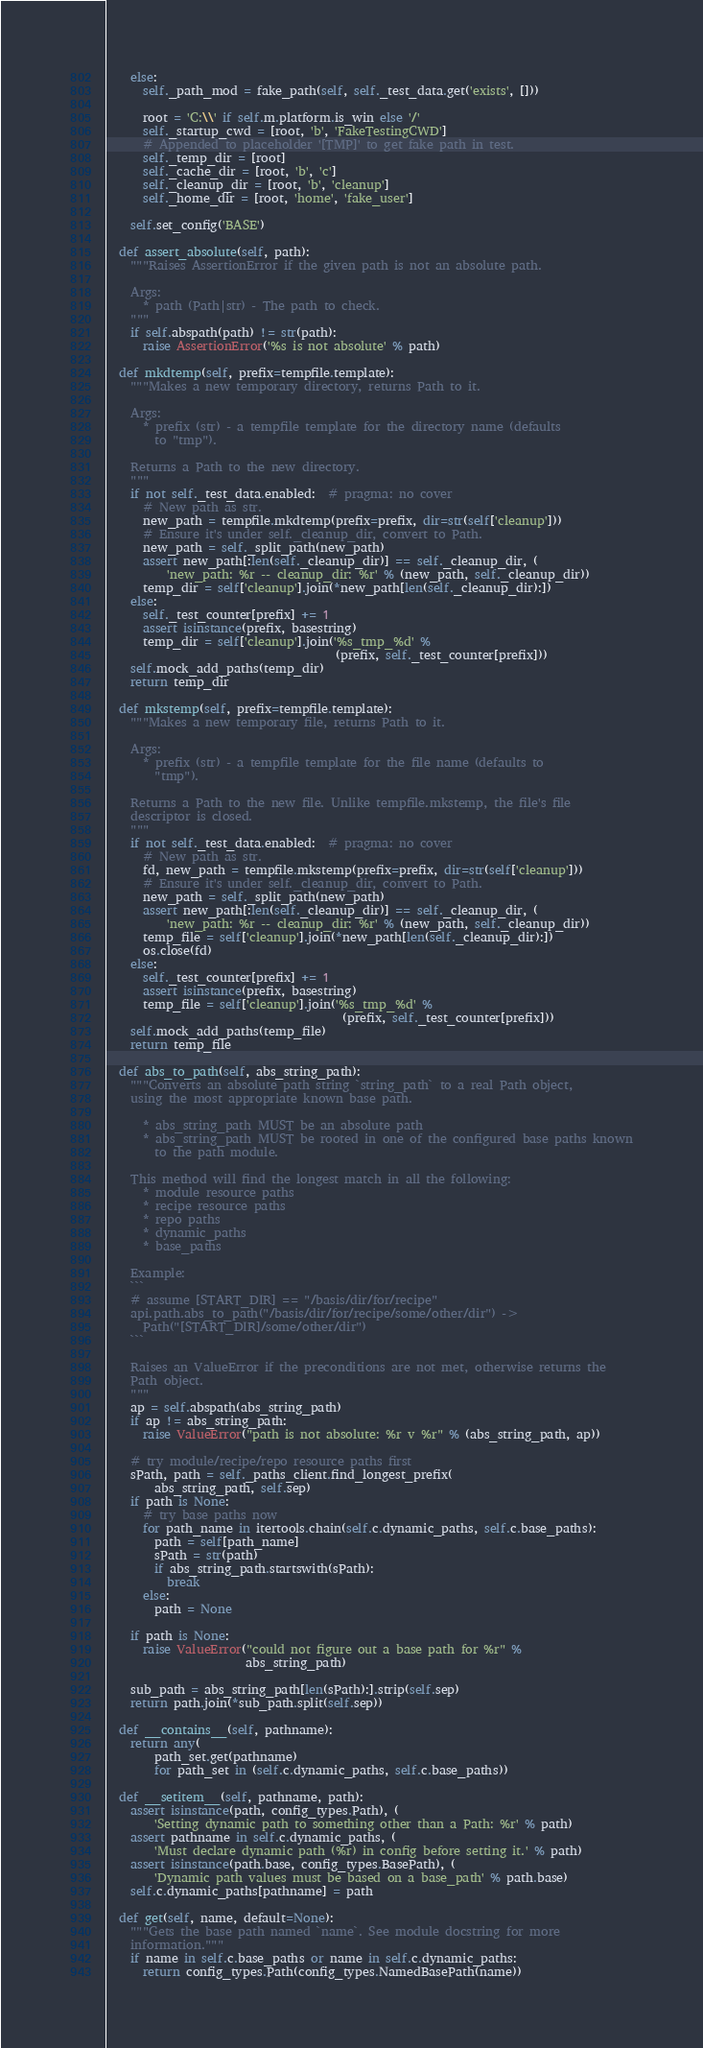Convert code to text. <code><loc_0><loc_0><loc_500><loc_500><_Python_>    else:
      self._path_mod = fake_path(self, self._test_data.get('exists', []))

      root = 'C:\\' if self.m.platform.is_win else '/'
      self._startup_cwd = [root, 'b', 'FakeTestingCWD']
      # Appended to placeholder '[TMP]' to get fake path in test.
      self._temp_dir = [root]
      self._cache_dir = [root, 'b', 'c']
      self._cleanup_dir = [root, 'b', 'cleanup']
      self._home_dir = [root, 'home', 'fake_user']

    self.set_config('BASE')

  def assert_absolute(self, path):
    """Raises AssertionError if the given path is not an absolute path.

    Args:
      * path (Path|str) - The path to check.
    """
    if self.abspath(path) != str(path):
      raise AssertionError('%s is not absolute' % path)

  def mkdtemp(self, prefix=tempfile.template):
    """Makes a new temporary directory, returns Path to it.

    Args:
      * prefix (str) - a tempfile template for the directory name (defaults
        to "tmp").

    Returns a Path to the new directory.
    """
    if not self._test_data.enabled:  # pragma: no cover
      # New path as str.
      new_path = tempfile.mkdtemp(prefix=prefix, dir=str(self['cleanup']))
      # Ensure it's under self._cleanup_dir, convert to Path.
      new_path = self._split_path(new_path)
      assert new_path[:len(self._cleanup_dir)] == self._cleanup_dir, (
          'new_path: %r -- cleanup_dir: %r' % (new_path, self._cleanup_dir))
      temp_dir = self['cleanup'].join(*new_path[len(self._cleanup_dir):])
    else:
      self._test_counter[prefix] += 1
      assert isinstance(prefix, basestring)
      temp_dir = self['cleanup'].join('%s_tmp_%d' %
                                      (prefix, self._test_counter[prefix]))
    self.mock_add_paths(temp_dir)
    return temp_dir

  def mkstemp(self, prefix=tempfile.template):
    """Makes a new temporary file, returns Path to it.

    Args:
      * prefix (str) - a tempfile template for the file name (defaults to
        "tmp").

    Returns a Path to the new file. Unlike tempfile.mkstemp, the file's file
    descriptor is closed.
    """
    if not self._test_data.enabled:  # pragma: no cover
      # New path as str.
      fd, new_path = tempfile.mkstemp(prefix=prefix, dir=str(self['cleanup']))
      # Ensure it's under self._cleanup_dir, convert to Path.
      new_path = self._split_path(new_path)
      assert new_path[:len(self._cleanup_dir)] == self._cleanup_dir, (
          'new_path: %r -- cleanup_dir: %r' % (new_path, self._cleanup_dir))
      temp_file = self['cleanup'].join(*new_path[len(self._cleanup_dir):])
      os.close(fd)
    else:
      self._test_counter[prefix] += 1
      assert isinstance(prefix, basestring)
      temp_file = self['cleanup'].join('%s_tmp_%d' %
                                       (prefix, self._test_counter[prefix]))
    self.mock_add_paths(temp_file)
    return temp_file

  def abs_to_path(self, abs_string_path):
    """Converts an absolute path string `string_path` to a real Path object,
    using the most appropriate known base path.

      * abs_string_path MUST be an absolute path
      * abs_string_path MUST be rooted in one of the configured base paths known
        to the path module.

    This method will find the longest match in all the following:
      * module resource paths
      * recipe resource paths
      * repo paths
      * dynamic_paths
      * base_paths

    Example:
    ```
    # assume [START_DIR] == "/basis/dir/for/recipe"
    api.path.abs_to_path("/basis/dir/for/recipe/some/other/dir") ->
      Path("[START_DIR]/some/other/dir")
    ```

    Raises an ValueError if the preconditions are not met, otherwise returns the
    Path object.
    """
    ap = self.abspath(abs_string_path)
    if ap != abs_string_path:
      raise ValueError("path is not absolute: %r v %r" % (abs_string_path, ap))

    # try module/recipe/repo resource paths first
    sPath, path = self._paths_client.find_longest_prefix(
        abs_string_path, self.sep)
    if path is None:
      # try base paths now
      for path_name in itertools.chain(self.c.dynamic_paths, self.c.base_paths):
        path = self[path_name]
        sPath = str(path)
        if abs_string_path.startswith(sPath):
          break
      else:
        path = None

    if path is None:
      raise ValueError("could not figure out a base path for %r" %
                       abs_string_path)

    sub_path = abs_string_path[len(sPath):].strip(self.sep)
    return path.join(*sub_path.split(self.sep))

  def __contains__(self, pathname):
    return any(
        path_set.get(pathname)
        for path_set in (self.c.dynamic_paths, self.c.base_paths))

  def __setitem__(self, pathname, path):
    assert isinstance(path, config_types.Path), (
        'Setting dynamic path to something other than a Path: %r' % path)
    assert pathname in self.c.dynamic_paths, (
        'Must declare dynamic path (%r) in config before setting it.' % path)
    assert isinstance(path.base, config_types.BasePath), (
        'Dynamic path values must be based on a base_path' % path.base)
    self.c.dynamic_paths[pathname] = path

  def get(self, name, default=None):
    """Gets the base path named `name`. See module docstring for more
    information."""
    if name in self.c.base_paths or name in self.c.dynamic_paths:
      return config_types.Path(config_types.NamedBasePath(name))</code> 